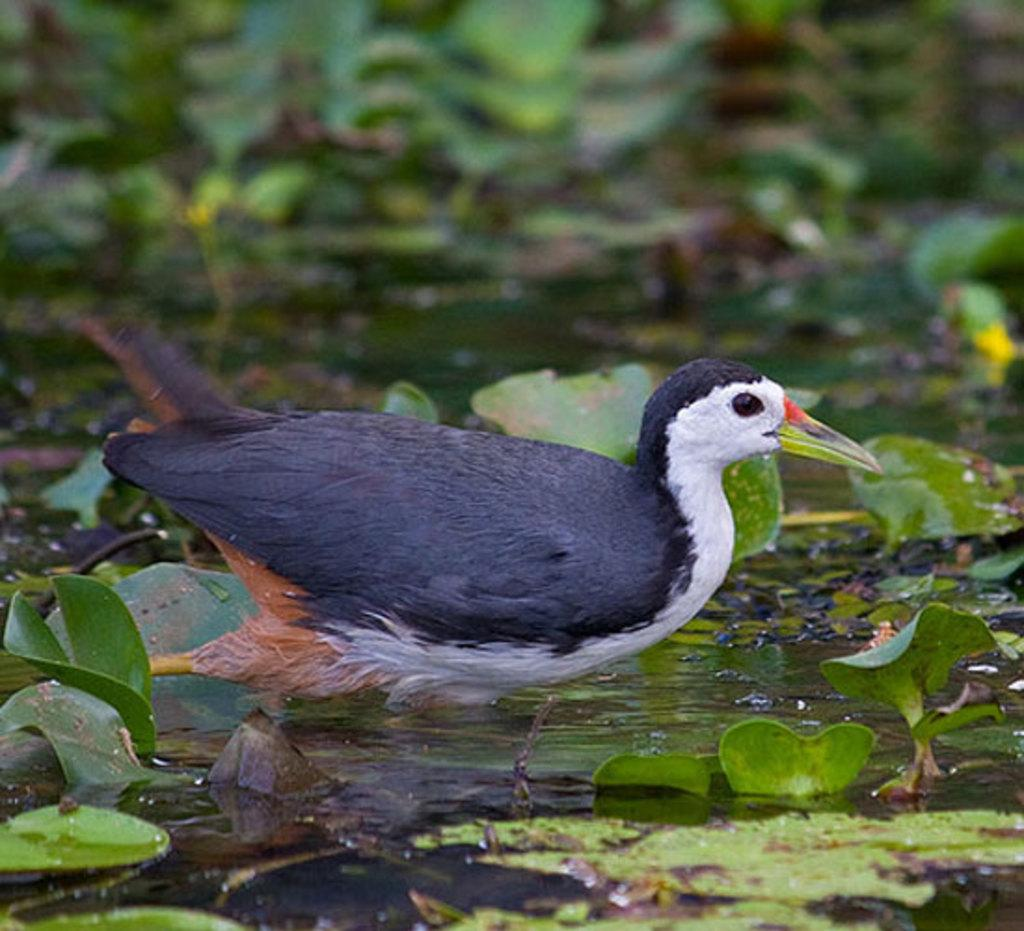What type of animal can be seen in the picture? There is a bird in the picture. What natural element is visible in the picture? Water is visible in the picture. What type of vegetation is present in the picture? Green leaves are present in the picture. How would you describe the background of the picture? The background portion of the picture is blurred. What type of industry can be seen in the picture? There is no industry present in the picture; it features a bird, water, green leaves, and a blurred background. What type of plant is growing in the basin in the picture? There is no basin or plant present in the picture. 